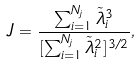<formula> <loc_0><loc_0><loc_500><loc_500>J = \frac { \sum _ { i = 1 } ^ { N _ { j } } \tilde { \lambda } _ { i } ^ { 3 } } { [ \sum _ { i = 1 } ^ { N _ { j } } \tilde { \lambda } _ { i } ^ { 2 } ] ^ { 3 / 2 } } ,</formula> 